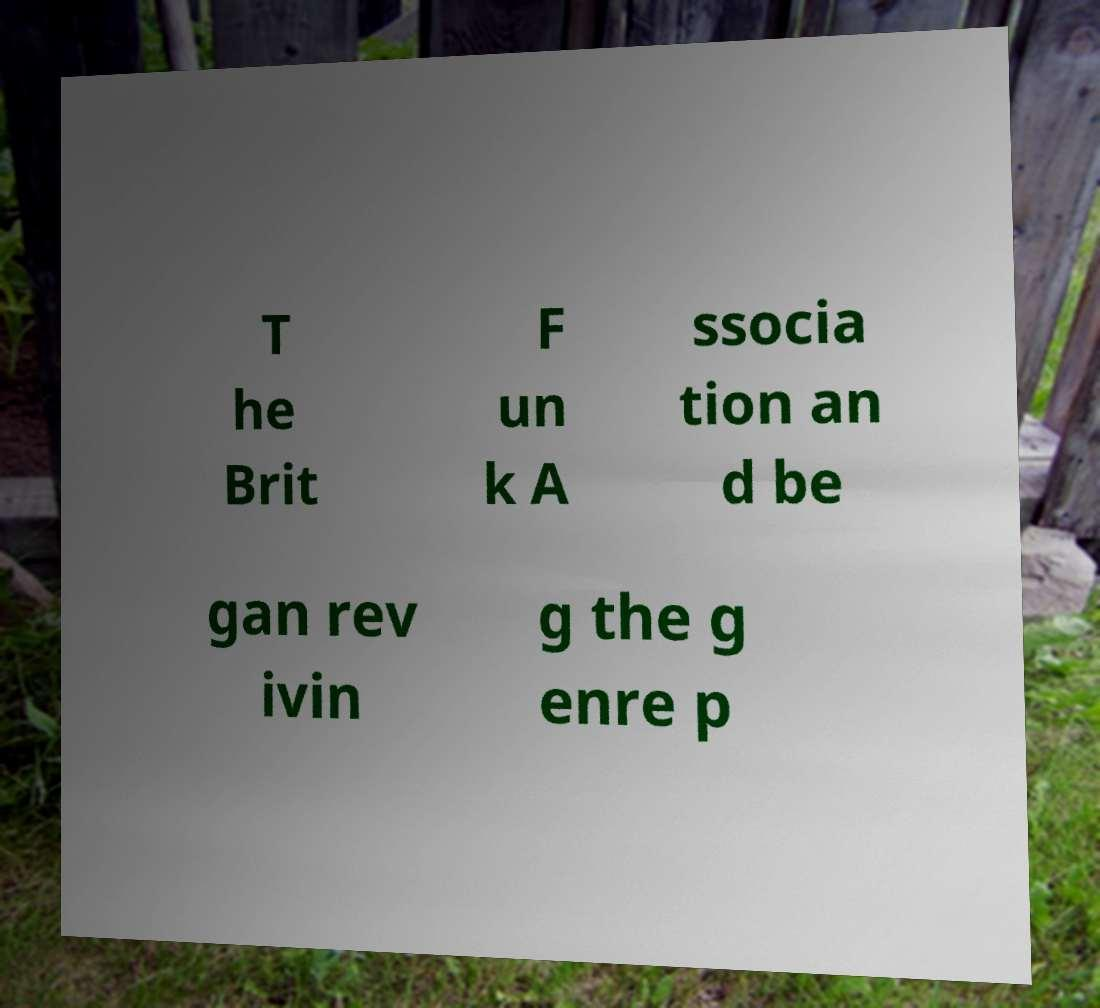For documentation purposes, I need the text within this image transcribed. Could you provide that? T he Brit F un k A ssocia tion an d be gan rev ivin g the g enre p 